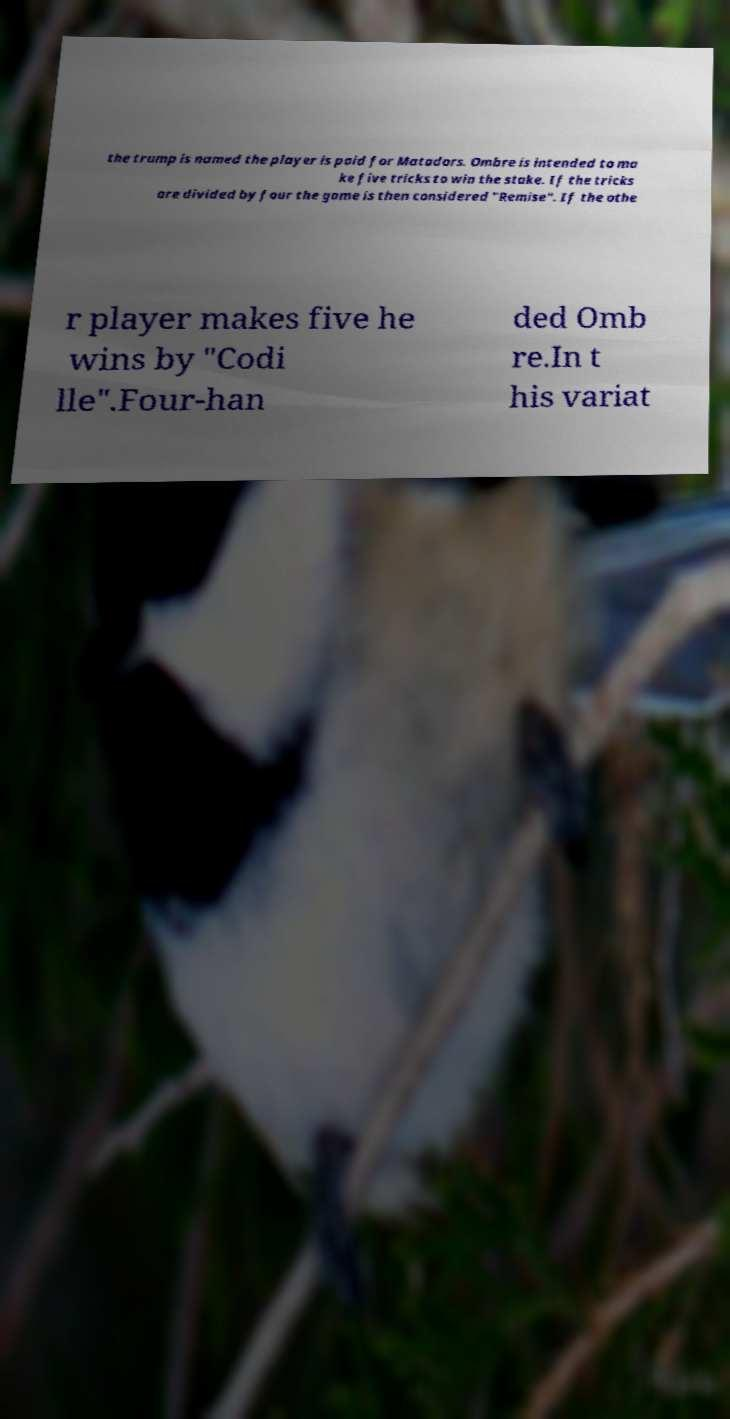Can you read and provide the text displayed in the image?This photo seems to have some interesting text. Can you extract and type it out for me? the trump is named the player is paid for Matadors. Ombre is intended to ma ke five tricks to win the stake. If the tricks are divided by four the game is then considered "Remise". If the othe r player makes five he wins by "Codi lle".Four-han ded Omb re.In t his variat 